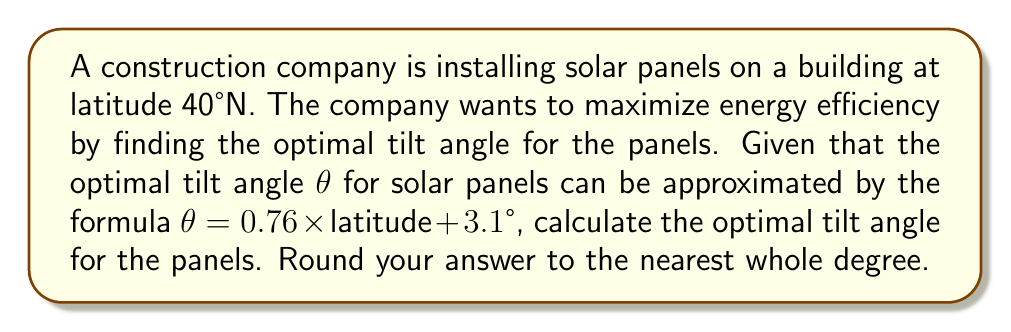Give your solution to this math problem. To solve this problem, we'll follow these steps:

1. Identify the given information:
   - Latitude: 40°N
   - Formula for optimal tilt angle: θ = 0.76 × latitude + 3.1°

2. Substitute the latitude into the formula:
   θ = 0.76 × 40 + 3.1°

3. Perform the multiplication:
   θ = 30.4 + 3.1°

4. Add the terms:
   θ = 33.5°

5. Round to the nearest whole degree:
   θ ≈ 34°

The optimal tilt angle for solar panels at 40°N latitude is approximately 34°.

[asy]
import geometry;

size(200);
defaultpen(fontsize(10pt));

pair O = (0,0);
pair A = (100,0);
pair B = (100,68);

draw(O--A--B--O);
draw(A--(100,-20), dashed);

label("Ground", (50,-10), S);
label("Solar Panel", (50,40), NW);
label("34°", (105,25), E);

markangle(n=1, radius=15, A,O,B, L="θ");
[/asy]

This angle ensures that the solar panels receive the maximum amount of direct sunlight throughout the year, taking into account the average position of the sun relative to the location's latitude.
Answer: 34° 